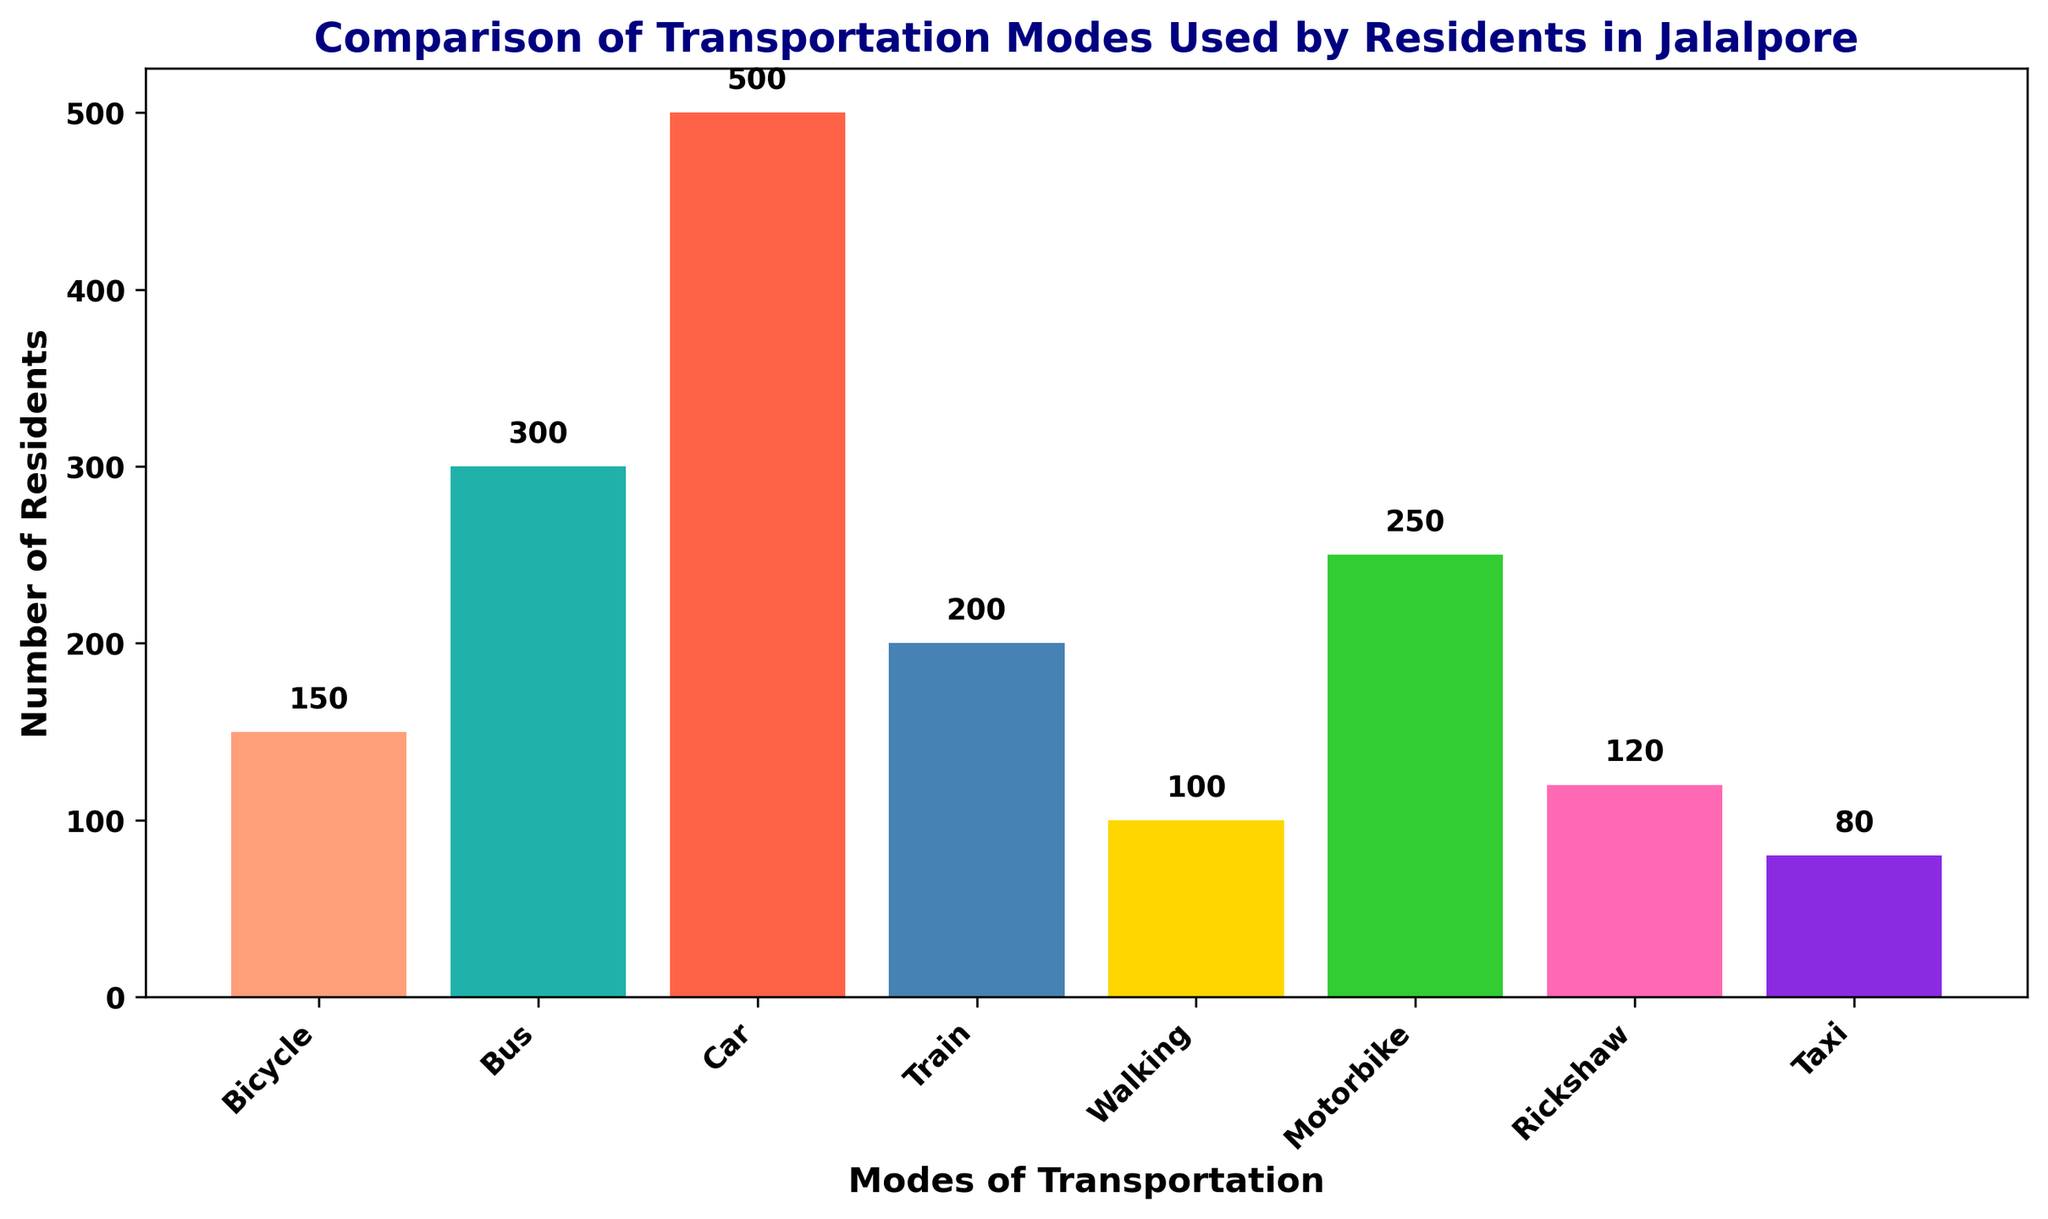What transportation mode is used by the highest number of residents? The height of the bar representing 'Car' is the tallest among all bars.
Answer: Car Which two transportation modes have the most similar number of residents? The heights of the bars representing 'Rickshaw' and 'Walking' are very close to each other.
Answer: Rickshaw and Walking What is the total number of residents that use either Train or Bus for transportation? The number of residents using Train is 200, and for Bus, it is 300. Adding these together: 200 + 300 = 500
Answer: 500 By how much does the number of residents using Motorbike exceed those using Bicycle? The number of residents using Motorbike is 250, and for Bicycle, it is 150. The difference is: 250 - 150 = 100
Answer: 100 Which transportation mode has the lowest number of residents, and how many residents use it? The height of the bar representing 'Taxi' is the shortest, indicating it has the least number of residents which is 80.
Answer: Taxi, 80 How many more residents use Car compared to Rickshaw? The number of residents using Car is 500, and for Rickshaw, it is 120. The difference is: 500 - 120 = 380
Answer: 380 Which transportation modes are used by fewer than 150 residents? The bars for Walking (100 residents) and Taxi (80 residents) are both below the 150 mark.
Answer: Walking and Taxi Calculate the average number of residents using non-motorized transportation modes (Bicycle and Walking). The number of residents for Bicycle is 150 and for Walking is 100. The sum is 150 + 100 = 250. The average is 250 / 2 = 125
Answer: 125 Compare the number of residents using Train with those using Motorbike. Which is higher and by how much? The number of residents using Train is 200 and for Motorbike is 250. The difference is: 250 - 200 = 50, with Motorbike being higher.
Answer: Motorbike, 50 What's the sum of residents using the three least popular transportation modes? The least popular modes are Taxi (80), Walking (100), and Rickshaw (120). The sum is: 80 + 100 + 120 = 300
Answer: 300 